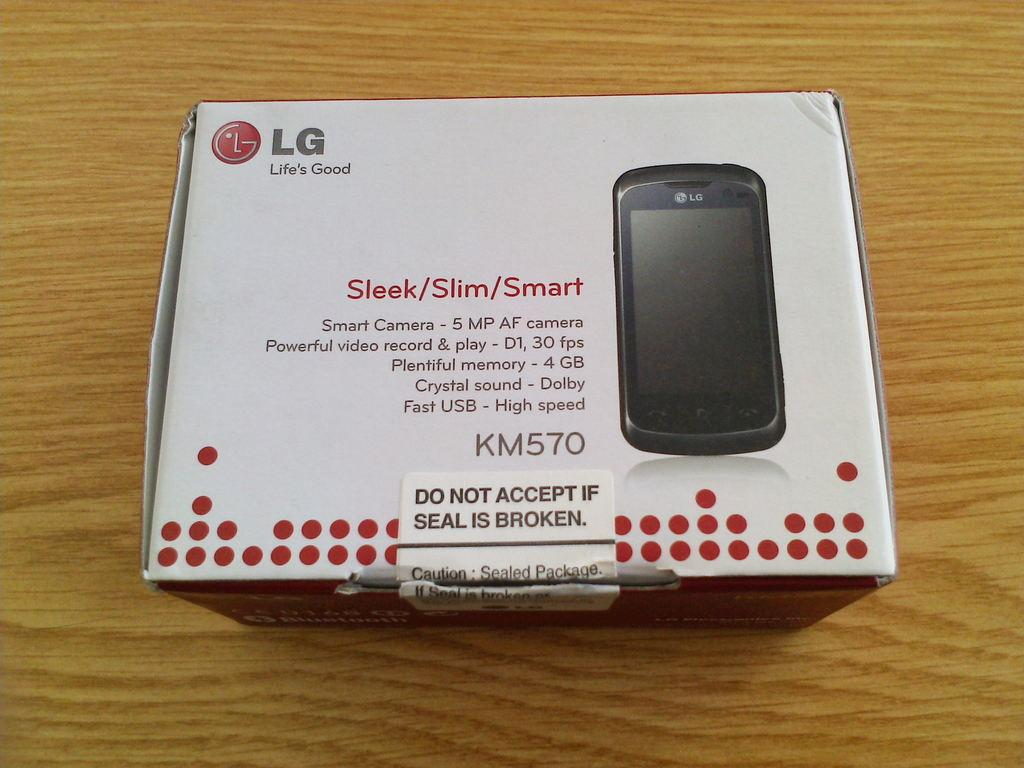<image>
Provide a brief description of the given image. a box that has LG written in the top left corner of it 